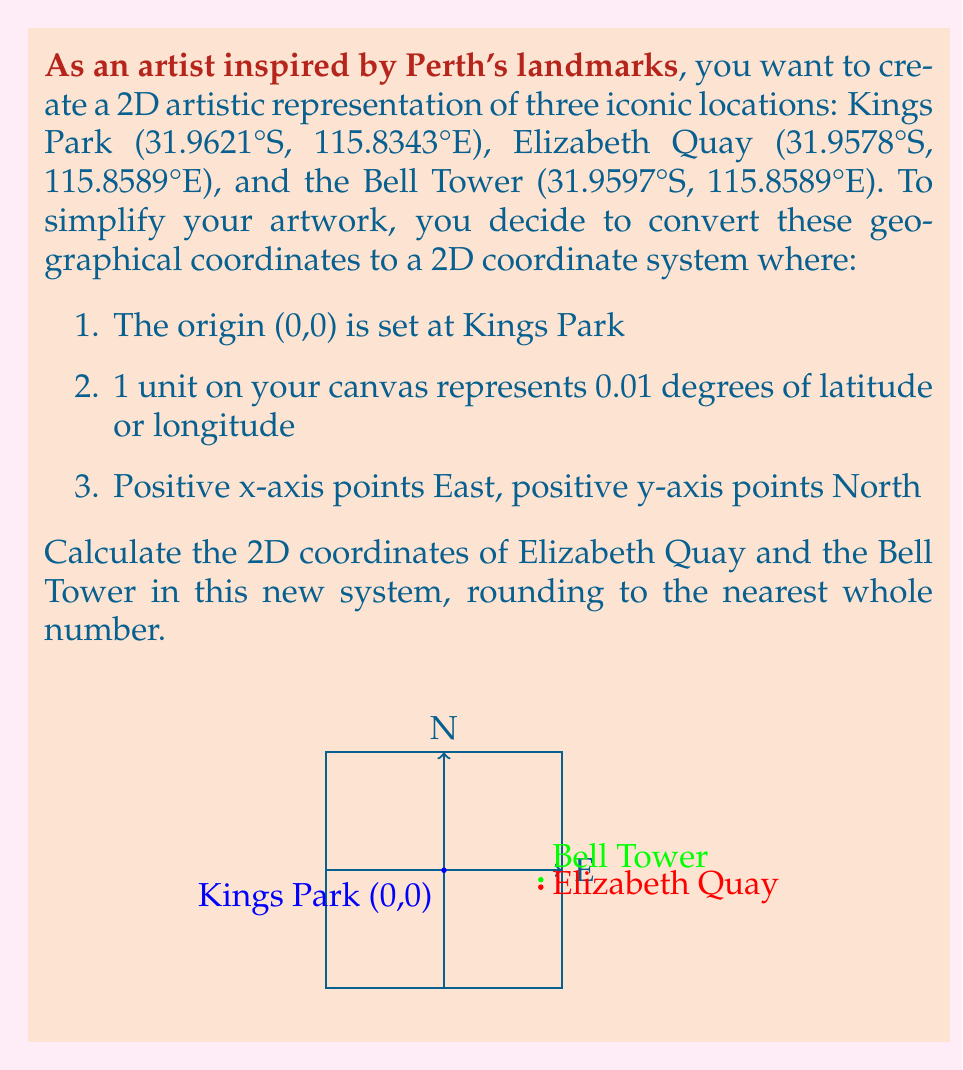Provide a solution to this math problem. Let's approach this step-by-step:

1) First, we need to calculate the differences in latitude and longitude between Kings Park and the other two locations:

   For Elizabeth Quay:
   Latitude difference: 31.9621°S - 31.9578°S = 0.0043° (North, positive)
   Longitude difference: 115.8589°E - 115.8343°E = 0.0246° (East, positive)

   For Bell Tower:
   Latitude difference: 31.9621°S - 31.9597°S = 0.0024° (North, positive)
   Longitude difference: 115.8589°E - 115.8343°E = 0.0246° (East, positive)

2) Now, we need to convert these differences to our new coordinate system where 1 unit = 0.01 degrees:

   Elizabeth Quay:
   x = 0.0246 / 0.01 = 2.46
   y = 0.0043 / 0.01 = 0.43

   Bell Tower:
   x = 0.0246 / 0.01 = 2.46
   y = 0.0024 / 0.01 = 0.24

3) Rounding to the nearest whole number:

   Elizabeth Quay: (2, 0)
   Bell Tower: (2, 0)

Note that both locations round to the same coordinates due to their proximity and our rounding criteria.
Answer: Elizabeth Quay: (2, 0), Bell Tower: (2, 0) 